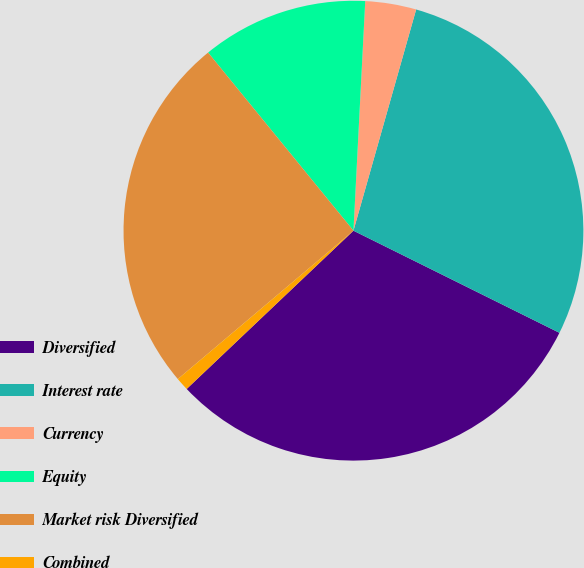Convert chart. <chart><loc_0><loc_0><loc_500><loc_500><pie_chart><fcel>Diversified<fcel>Interest rate<fcel>Currency<fcel>Equity<fcel>Market risk Diversified<fcel>Combined<nl><fcel>30.59%<fcel>27.93%<fcel>3.58%<fcel>11.71%<fcel>25.27%<fcel>0.92%<nl></chart> 